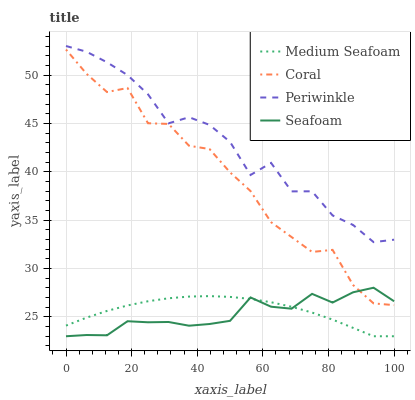Does Seafoam have the minimum area under the curve?
Answer yes or no. Yes. Does Periwinkle have the maximum area under the curve?
Answer yes or no. Yes. Does Medium Seafoam have the minimum area under the curve?
Answer yes or no. No. Does Medium Seafoam have the maximum area under the curve?
Answer yes or no. No. Is Medium Seafoam the smoothest?
Answer yes or no. Yes. Is Coral the roughest?
Answer yes or no. Yes. Is Periwinkle the smoothest?
Answer yes or no. No. Is Periwinkle the roughest?
Answer yes or no. No. Does Medium Seafoam have the lowest value?
Answer yes or no. Yes. Does Periwinkle have the lowest value?
Answer yes or no. No. Does Periwinkle have the highest value?
Answer yes or no. Yes. Does Medium Seafoam have the highest value?
Answer yes or no. No. Is Coral less than Periwinkle?
Answer yes or no. Yes. Is Coral greater than Medium Seafoam?
Answer yes or no. Yes. Does Seafoam intersect Coral?
Answer yes or no. Yes. Is Seafoam less than Coral?
Answer yes or no. No. Is Seafoam greater than Coral?
Answer yes or no. No. Does Coral intersect Periwinkle?
Answer yes or no. No. 